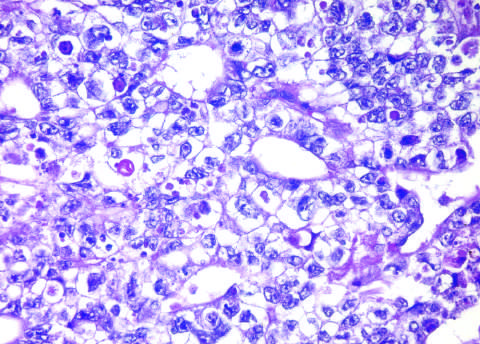s a mallory-denk body hemorrhagic?
Answer the question using a single word or phrase. No 